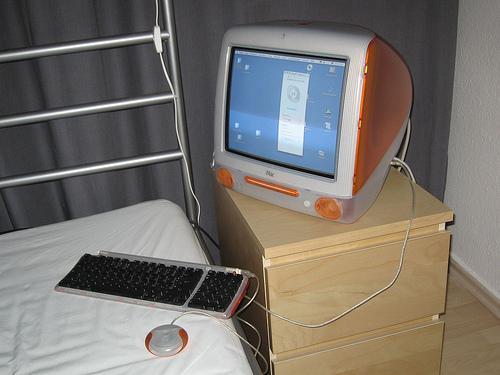How many keyboards are there?
Give a very brief answer. 1. 